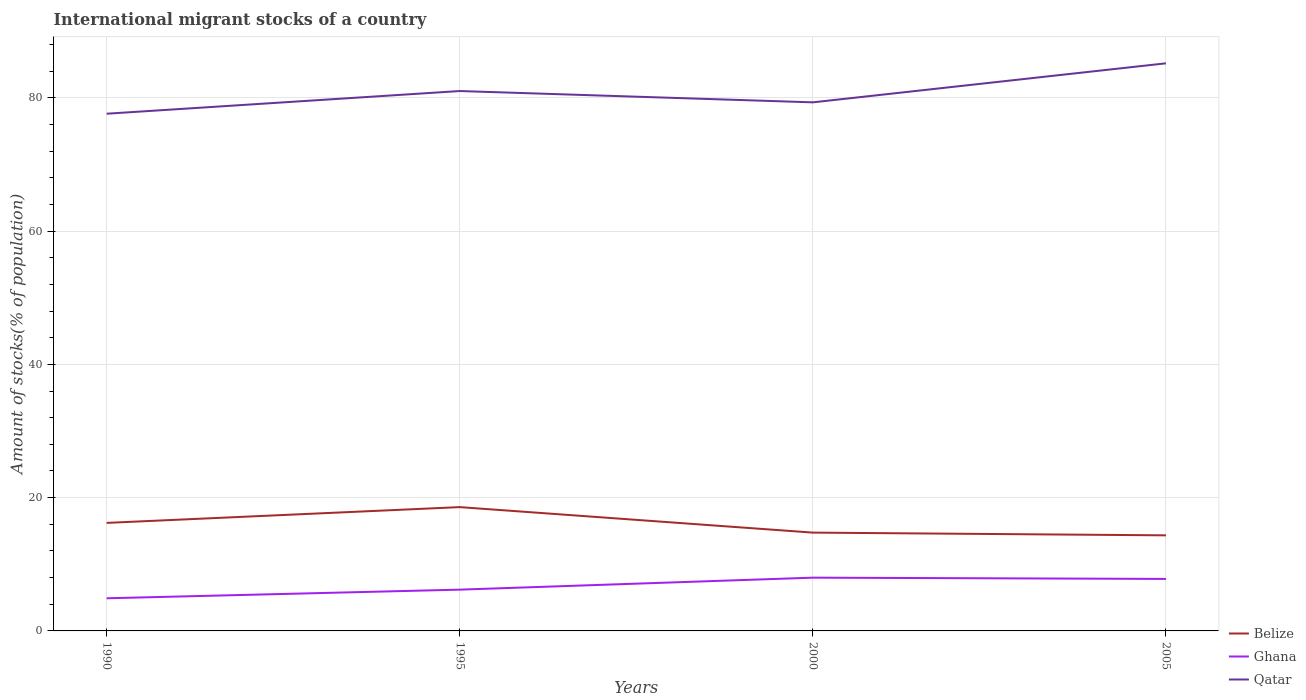How many different coloured lines are there?
Offer a very short reply. 3. Does the line corresponding to Belize intersect with the line corresponding to Ghana?
Your answer should be compact. No. Across all years, what is the maximum amount of stocks in in Ghana?
Your answer should be very brief. 4.9. In which year was the amount of stocks in in Qatar maximum?
Your answer should be compact. 1990. What is the total amount of stocks in in Belize in the graph?
Offer a very short reply. 0.41. What is the difference between the highest and the second highest amount of stocks in in Ghana?
Provide a succinct answer. 3.09. What is the difference between the highest and the lowest amount of stocks in in Qatar?
Keep it short and to the point. 2. How many years are there in the graph?
Offer a terse response. 4. What is the difference between two consecutive major ticks on the Y-axis?
Your answer should be compact. 20. Are the values on the major ticks of Y-axis written in scientific E-notation?
Your response must be concise. No. Does the graph contain grids?
Make the answer very short. Yes. Where does the legend appear in the graph?
Your answer should be very brief. Bottom right. How many legend labels are there?
Provide a short and direct response. 3. How are the legend labels stacked?
Provide a short and direct response. Vertical. What is the title of the graph?
Make the answer very short. International migrant stocks of a country. Does "Belarus" appear as one of the legend labels in the graph?
Give a very brief answer. No. What is the label or title of the Y-axis?
Your response must be concise. Amount of stocks(% of population). What is the Amount of stocks(% of population) of Belize in 1990?
Offer a very short reply. 16.21. What is the Amount of stocks(% of population) in Ghana in 1990?
Provide a succinct answer. 4.9. What is the Amount of stocks(% of population) of Qatar in 1990?
Offer a terse response. 77.61. What is the Amount of stocks(% of population) of Belize in 1995?
Give a very brief answer. 18.58. What is the Amount of stocks(% of population) in Ghana in 1995?
Keep it short and to the point. 6.2. What is the Amount of stocks(% of population) in Qatar in 1995?
Give a very brief answer. 81.02. What is the Amount of stocks(% of population) in Belize in 2000?
Provide a short and direct response. 14.75. What is the Amount of stocks(% of population) in Ghana in 2000?
Keep it short and to the point. 7.99. What is the Amount of stocks(% of population) in Qatar in 2000?
Keep it short and to the point. 79.32. What is the Amount of stocks(% of population) of Belize in 2005?
Make the answer very short. 14.34. What is the Amount of stocks(% of population) of Ghana in 2005?
Keep it short and to the point. 7.8. What is the Amount of stocks(% of population) in Qatar in 2005?
Offer a terse response. 85.18. Across all years, what is the maximum Amount of stocks(% of population) in Belize?
Make the answer very short. 18.58. Across all years, what is the maximum Amount of stocks(% of population) of Ghana?
Provide a succinct answer. 7.99. Across all years, what is the maximum Amount of stocks(% of population) in Qatar?
Keep it short and to the point. 85.18. Across all years, what is the minimum Amount of stocks(% of population) of Belize?
Ensure brevity in your answer.  14.34. Across all years, what is the minimum Amount of stocks(% of population) of Ghana?
Your answer should be compact. 4.9. Across all years, what is the minimum Amount of stocks(% of population) in Qatar?
Give a very brief answer. 77.61. What is the total Amount of stocks(% of population) in Belize in the graph?
Provide a short and direct response. 63.89. What is the total Amount of stocks(% of population) of Ghana in the graph?
Your response must be concise. 26.89. What is the total Amount of stocks(% of population) in Qatar in the graph?
Keep it short and to the point. 323.13. What is the difference between the Amount of stocks(% of population) of Belize in 1990 and that in 1995?
Your answer should be compact. -2.37. What is the difference between the Amount of stocks(% of population) of Ghana in 1990 and that in 1995?
Ensure brevity in your answer.  -1.3. What is the difference between the Amount of stocks(% of population) of Qatar in 1990 and that in 1995?
Offer a very short reply. -3.4. What is the difference between the Amount of stocks(% of population) in Belize in 1990 and that in 2000?
Offer a very short reply. 1.46. What is the difference between the Amount of stocks(% of population) of Ghana in 1990 and that in 2000?
Your answer should be compact. -3.09. What is the difference between the Amount of stocks(% of population) in Qatar in 1990 and that in 2000?
Your answer should be compact. -1.71. What is the difference between the Amount of stocks(% of population) in Belize in 1990 and that in 2005?
Provide a succinct answer. 1.87. What is the difference between the Amount of stocks(% of population) in Ghana in 1990 and that in 2005?
Give a very brief answer. -2.91. What is the difference between the Amount of stocks(% of population) of Qatar in 1990 and that in 2005?
Your answer should be compact. -7.56. What is the difference between the Amount of stocks(% of population) of Belize in 1995 and that in 2000?
Your answer should be compact. 3.82. What is the difference between the Amount of stocks(% of population) of Ghana in 1995 and that in 2000?
Give a very brief answer. -1.8. What is the difference between the Amount of stocks(% of population) of Qatar in 1995 and that in 2000?
Your answer should be very brief. 1.7. What is the difference between the Amount of stocks(% of population) of Belize in 1995 and that in 2005?
Your response must be concise. 4.24. What is the difference between the Amount of stocks(% of population) in Ghana in 1995 and that in 2005?
Offer a very short reply. -1.61. What is the difference between the Amount of stocks(% of population) in Qatar in 1995 and that in 2005?
Give a very brief answer. -4.16. What is the difference between the Amount of stocks(% of population) of Belize in 2000 and that in 2005?
Your response must be concise. 0.41. What is the difference between the Amount of stocks(% of population) of Ghana in 2000 and that in 2005?
Your answer should be compact. 0.19. What is the difference between the Amount of stocks(% of population) in Qatar in 2000 and that in 2005?
Your response must be concise. -5.86. What is the difference between the Amount of stocks(% of population) of Belize in 1990 and the Amount of stocks(% of population) of Ghana in 1995?
Your response must be concise. 10.02. What is the difference between the Amount of stocks(% of population) in Belize in 1990 and the Amount of stocks(% of population) in Qatar in 1995?
Provide a short and direct response. -64.81. What is the difference between the Amount of stocks(% of population) in Ghana in 1990 and the Amount of stocks(% of population) in Qatar in 1995?
Give a very brief answer. -76.12. What is the difference between the Amount of stocks(% of population) in Belize in 1990 and the Amount of stocks(% of population) in Ghana in 2000?
Your answer should be compact. 8.22. What is the difference between the Amount of stocks(% of population) of Belize in 1990 and the Amount of stocks(% of population) of Qatar in 2000?
Give a very brief answer. -63.11. What is the difference between the Amount of stocks(% of population) in Ghana in 1990 and the Amount of stocks(% of population) in Qatar in 2000?
Keep it short and to the point. -74.42. What is the difference between the Amount of stocks(% of population) of Belize in 1990 and the Amount of stocks(% of population) of Ghana in 2005?
Keep it short and to the point. 8.41. What is the difference between the Amount of stocks(% of population) of Belize in 1990 and the Amount of stocks(% of population) of Qatar in 2005?
Offer a terse response. -68.97. What is the difference between the Amount of stocks(% of population) in Ghana in 1990 and the Amount of stocks(% of population) in Qatar in 2005?
Your answer should be compact. -80.28. What is the difference between the Amount of stocks(% of population) in Belize in 1995 and the Amount of stocks(% of population) in Ghana in 2000?
Give a very brief answer. 10.59. What is the difference between the Amount of stocks(% of population) in Belize in 1995 and the Amount of stocks(% of population) in Qatar in 2000?
Your response must be concise. -60.74. What is the difference between the Amount of stocks(% of population) of Ghana in 1995 and the Amount of stocks(% of population) of Qatar in 2000?
Offer a very short reply. -73.13. What is the difference between the Amount of stocks(% of population) of Belize in 1995 and the Amount of stocks(% of population) of Ghana in 2005?
Offer a terse response. 10.77. What is the difference between the Amount of stocks(% of population) of Belize in 1995 and the Amount of stocks(% of population) of Qatar in 2005?
Your response must be concise. -66.6. What is the difference between the Amount of stocks(% of population) in Ghana in 1995 and the Amount of stocks(% of population) in Qatar in 2005?
Make the answer very short. -78.98. What is the difference between the Amount of stocks(% of population) in Belize in 2000 and the Amount of stocks(% of population) in Ghana in 2005?
Provide a short and direct response. 6.95. What is the difference between the Amount of stocks(% of population) of Belize in 2000 and the Amount of stocks(% of population) of Qatar in 2005?
Offer a very short reply. -70.42. What is the difference between the Amount of stocks(% of population) of Ghana in 2000 and the Amount of stocks(% of population) of Qatar in 2005?
Your answer should be very brief. -77.18. What is the average Amount of stocks(% of population) in Belize per year?
Offer a very short reply. 15.97. What is the average Amount of stocks(% of population) in Ghana per year?
Provide a succinct answer. 6.72. What is the average Amount of stocks(% of population) of Qatar per year?
Make the answer very short. 80.78. In the year 1990, what is the difference between the Amount of stocks(% of population) of Belize and Amount of stocks(% of population) of Ghana?
Your answer should be compact. 11.31. In the year 1990, what is the difference between the Amount of stocks(% of population) in Belize and Amount of stocks(% of population) in Qatar?
Keep it short and to the point. -61.4. In the year 1990, what is the difference between the Amount of stocks(% of population) in Ghana and Amount of stocks(% of population) in Qatar?
Offer a very short reply. -72.72. In the year 1995, what is the difference between the Amount of stocks(% of population) of Belize and Amount of stocks(% of population) of Ghana?
Give a very brief answer. 12.38. In the year 1995, what is the difference between the Amount of stocks(% of population) of Belize and Amount of stocks(% of population) of Qatar?
Provide a short and direct response. -62.44. In the year 1995, what is the difference between the Amount of stocks(% of population) in Ghana and Amount of stocks(% of population) in Qatar?
Offer a terse response. -74.82. In the year 2000, what is the difference between the Amount of stocks(% of population) in Belize and Amount of stocks(% of population) in Ghana?
Ensure brevity in your answer.  6.76. In the year 2000, what is the difference between the Amount of stocks(% of population) in Belize and Amount of stocks(% of population) in Qatar?
Your answer should be compact. -64.57. In the year 2000, what is the difference between the Amount of stocks(% of population) of Ghana and Amount of stocks(% of population) of Qatar?
Keep it short and to the point. -71.33. In the year 2005, what is the difference between the Amount of stocks(% of population) in Belize and Amount of stocks(% of population) in Ghana?
Offer a very short reply. 6.54. In the year 2005, what is the difference between the Amount of stocks(% of population) in Belize and Amount of stocks(% of population) in Qatar?
Give a very brief answer. -70.83. In the year 2005, what is the difference between the Amount of stocks(% of population) of Ghana and Amount of stocks(% of population) of Qatar?
Offer a terse response. -77.37. What is the ratio of the Amount of stocks(% of population) in Belize in 1990 to that in 1995?
Provide a short and direct response. 0.87. What is the ratio of the Amount of stocks(% of population) of Ghana in 1990 to that in 1995?
Ensure brevity in your answer.  0.79. What is the ratio of the Amount of stocks(% of population) in Qatar in 1990 to that in 1995?
Your response must be concise. 0.96. What is the ratio of the Amount of stocks(% of population) in Belize in 1990 to that in 2000?
Offer a very short reply. 1.1. What is the ratio of the Amount of stocks(% of population) of Ghana in 1990 to that in 2000?
Give a very brief answer. 0.61. What is the ratio of the Amount of stocks(% of population) of Qatar in 1990 to that in 2000?
Your response must be concise. 0.98. What is the ratio of the Amount of stocks(% of population) of Belize in 1990 to that in 2005?
Make the answer very short. 1.13. What is the ratio of the Amount of stocks(% of population) in Ghana in 1990 to that in 2005?
Provide a succinct answer. 0.63. What is the ratio of the Amount of stocks(% of population) of Qatar in 1990 to that in 2005?
Ensure brevity in your answer.  0.91. What is the ratio of the Amount of stocks(% of population) of Belize in 1995 to that in 2000?
Give a very brief answer. 1.26. What is the ratio of the Amount of stocks(% of population) of Ghana in 1995 to that in 2000?
Your answer should be very brief. 0.78. What is the ratio of the Amount of stocks(% of population) in Qatar in 1995 to that in 2000?
Make the answer very short. 1.02. What is the ratio of the Amount of stocks(% of population) of Belize in 1995 to that in 2005?
Provide a succinct answer. 1.3. What is the ratio of the Amount of stocks(% of population) in Ghana in 1995 to that in 2005?
Offer a terse response. 0.79. What is the ratio of the Amount of stocks(% of population) of Qatar in 1995 to that in 2005?
Make the answer very short. 0.95. What is the ratio of the Amount of stocks(% of population) of Belize in 2000 to that in 2005?
Make the answer very short. 1.03. What is the ratio of the Amount of stocks(% of population) of Ghana in 2000 to that in 2005?
Provide a short and direct response. 1.02. What is the ratio of the Amount of stocks(% of population) in Qatar in 2000 to that in 2005?
Your answer should be compact. 0.93. What is the difference between the highest and the second highest Amount of stocks(% of population) in Belize?
Provide a short and direct response. 2.37. What is the difference between the highest and the second highest Amount of stocks(% of population) of Ghana?
Your answer should be compact. 0.19. What is the difference between the highest and the second highest Amount of stocks(% of population) of Qatar?
Provide a succinct answer. 4.16. What is the difference between the highest and the lowest Amount of stocks(% of population) in Belize?
Your answer should be very brief. 4.24. What is the difference between the highest and the lowest Amount of stocks(% of population) of Ghana?
Offer a very short reply. 3.09. What is the difference between the highest and the lowest Amount of stocks(% of population) of Qatar?
Give a very brief answer. 7.56. 